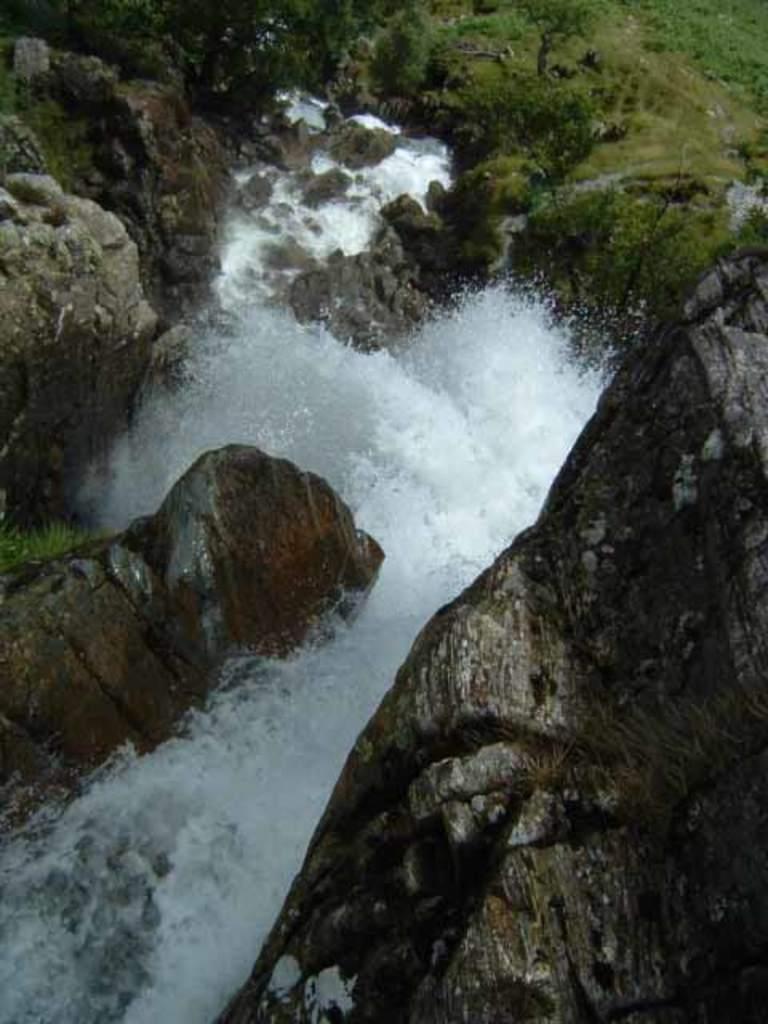Can you describe this image briefly? In front of the image there are rocks, water. There are plants. At the bottom of the image there is grass on the surface. 